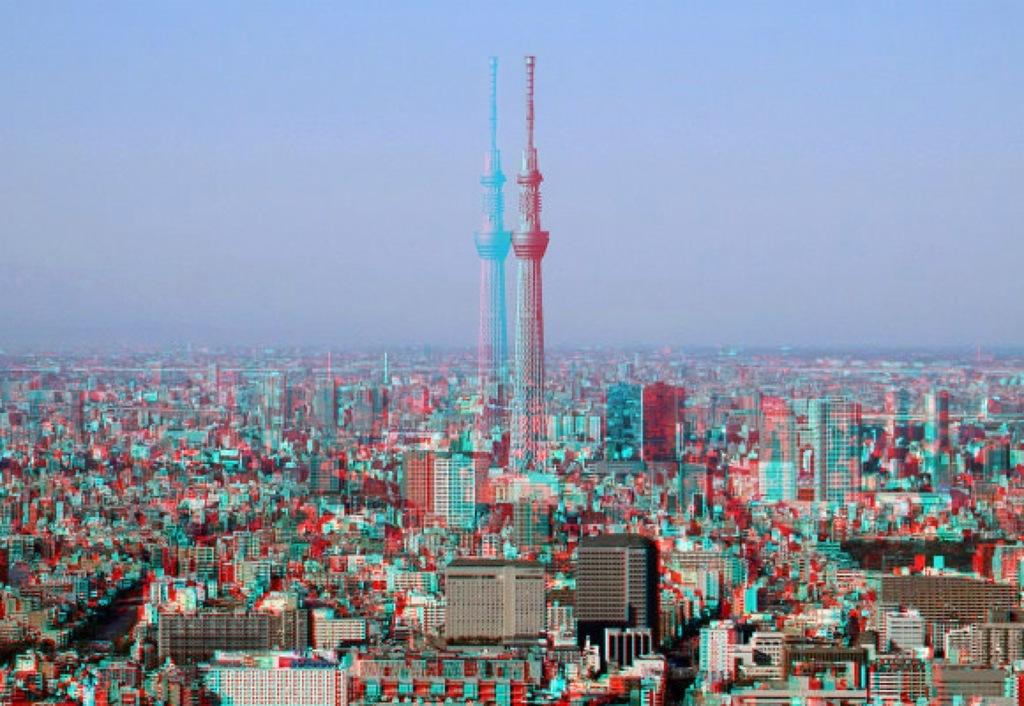What type of structures can be seen in the image? There are many buildings in the image. What is the most prominent structure in the image? There is a tower at the center of the image. What is the condition of the sky in the image? The sky is clear in the image. How would you describe the quality of the image? The image is blurred. What type of skirt is the tower wearing in the image? The tower is not a person and therefore cannot wear a skirt. 